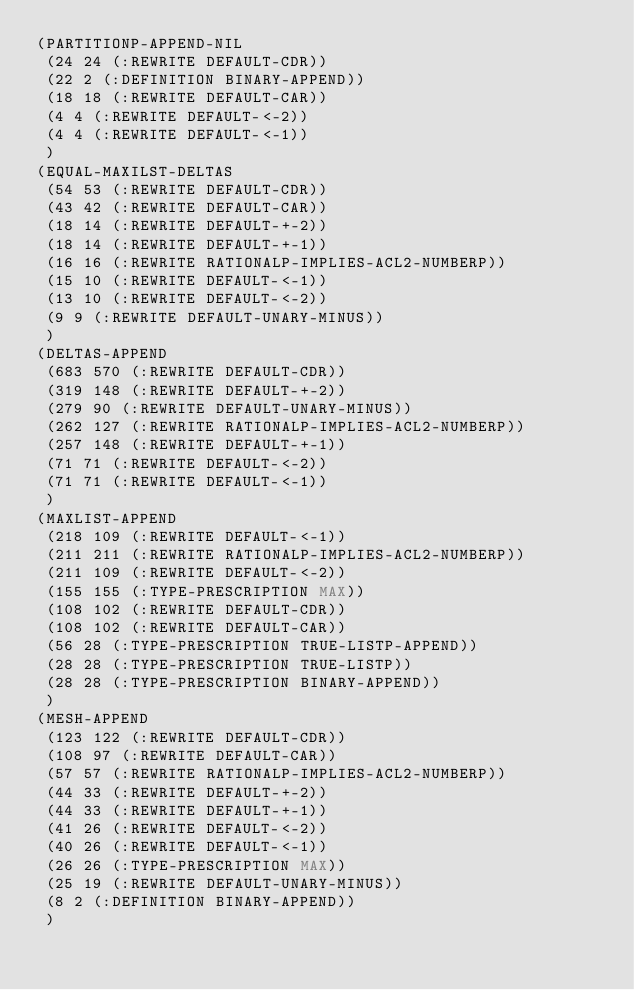<code> <loc_0><loc_0><loc_500><loc_500><_Lisp_>(PARTITIONP-APPEND-NIL
 (24 24 (:REWRITE DEFAULT-CDR))
 (22 2 (:DEFINITION BINARY-APPEND))
 (18 18 (:REWRITE DEFAULT-CAR))
 (4 4 (:REWRITE DEFAULT-<-2))
 (4 4 (:REWRITE DEFAULT-<-1))
 )
(EQUAL-MAXILST-DELTAS
 (54 53 (:REWRITE DEFAULT-CDR))
 (43 42 (:REWRITE DEFAULT-CAR))
 (18 14 (:REWRITE DEFAULT-+-2))
 (18 14 (:REWRITE DEFAULT-+-1))
 (16 16 (:REWRITE RATIONALP-IMPLIES-ACL2-NUMBERP))
 (15 10 (:REWRITE DEFAULT-<-1))
 (13 10 (:REWRITE DEFAULT-<-2))
 (9 9 (:REWRITE DEFAULT-UNARY-MINUS))
 )
(DELTAS-APPEND
 (683 570 (:REWRITE DEFAULT-CDR))
 (319 148 (:REWRITE DEFAULT-+-2))
 (279 90 (:REWRITE DEFAULT-UNARY-MINUS))
 (262 127 (:REWRITE RATIONALP-IMPLIES-ACL2-NUMBERP))
 (257 148 (:REWRITE DEFAULT-+-1))
 (71 71 (:REWRITE DEFAULT-<-2))
 (71 71 (:REWRITE DEFAULT-<-1))
 )
(MAXLIST-APPEND
 (218 109 (:REWRITE DEFAULT-<-1))
 (211 211 (:REWRITE RATIONALP-IMPLIES-ACL2-NUMBERP))
 (211 109 (:REWRITE DEFAULT-<-2))
 (155 155 (:TYPE-PRESCRIPTION MAX))
 (108 102 (:REWRITE DEFAULT-CDR))
 (108 102 (:REWRITE DEFAULT-CAR))
 (56 28 (:TYPE-PRESCRIPTION TRUE-LISTP-APPEND))
 (28 28 (:TYPE-PRESCRIPTION TRUE-LISTP))
 (28 28 (:TYPE-PRESCRIPTION BINARY-APPEND))
 )
(MESH-APPEND
 (123 122 (:REWRITE DEFAULT-CDR))
 (108 97 (:REWRITE DEFAULT-CAR))
 (57 57 (:REWRITE RATIONALP-IMPLIES-ACL2-NUMBERP))
 (44 33 (:REWRITE DEFAULT-+-2))
 (44 33 (:REWRITE DEFAULT-+-1))
 (41 26 (:REWRITE DEFAULT-<-2))
 (40 26 (:REWRITE DEFAULT-<-1))
 (26 26 (:TYPE-PRESCRIPTION MAX))
 (25 19 (:REWRITE DEFAULT-UNARY-MINUS))
 (8 2 (:DEFINITION BINARY-APPEND))
 )
</code> 